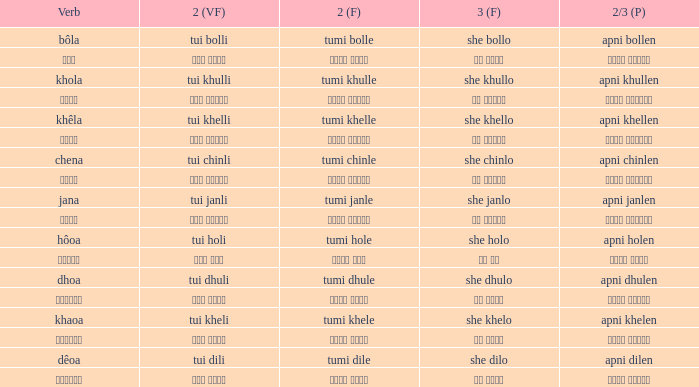What is the 3rd for the 2nd Tui Dhuli? She dhulo. 